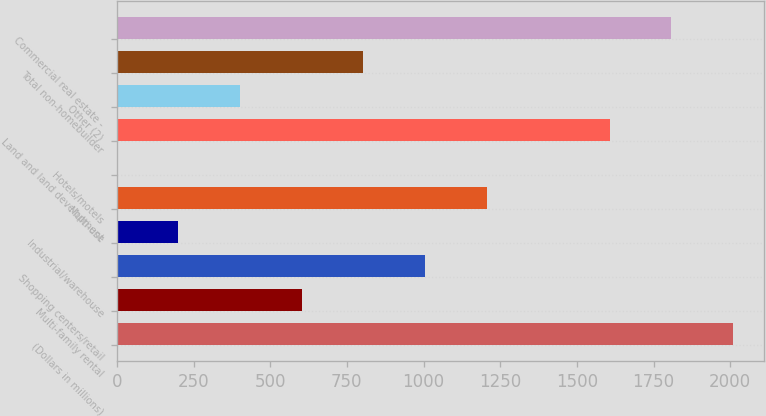Convert chart to OTSL. <chart><loc_0><loc_0><loc_500><loc_500><bar_chart><fcel>(Dollars in millions)<fcel>Multi-family rental<fcel>Shopping centers/retail<fcel>Industrial/warehouse<fcel>Multi-use<fcel>Hotels/motels<fcel>Land and land development<fcel>Other (2)<fcel>Total non-homebuilder<fcel>Commercial real estate -<nl><fcel>2009<fcel>602.75<fcel>1004.53<fcel>200.97<fcel>1205.42<fcel>0.08<fcel>1607.2<fcel>401.86<fcel>803.64<fcel>1808.09<nl></chart> 